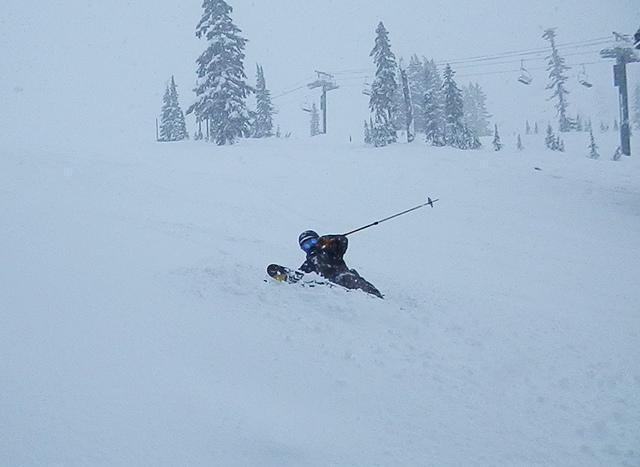How many people are skiing?
Give a very brief answer. 1. How many cola bottles are there?
Give a very brief answer. 0. 